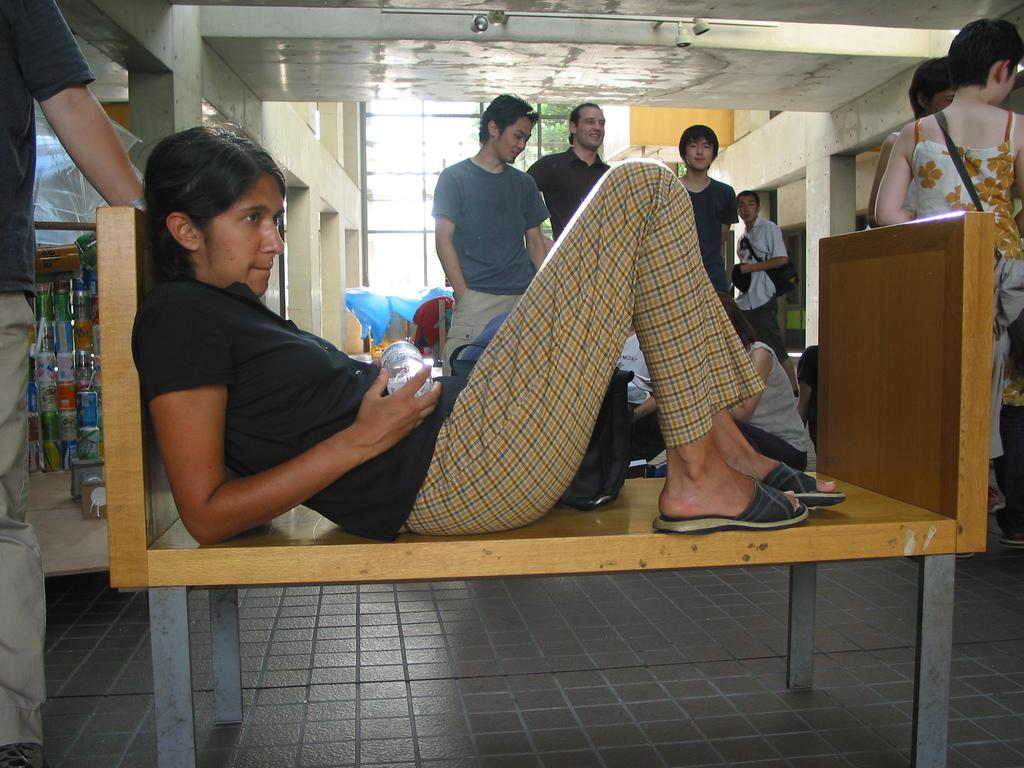What is the woman in the image doing? The woman is laying on a bench in the image. Are there any other people present in the image? Yes, there are people around the woman. What can be seen on the left side of the image? There are objects on the left side of the image. What is visible in the background of the image? There is a window in the background of the image. How does the woman mark her progress on the station in the image? There is no station or marking progress present in the image; it features a woman laying on a bench with people around her and a window in the background. 